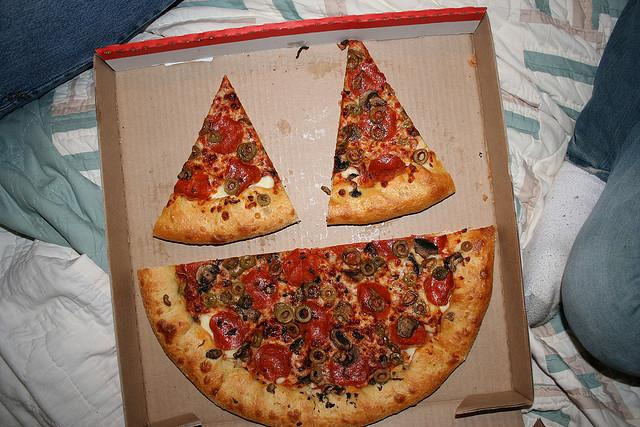Which topping contains the highest level of sodium? Please explain your reasoning. pepperoni. The other ingredients usually don't have as much sodium as cured meat. 